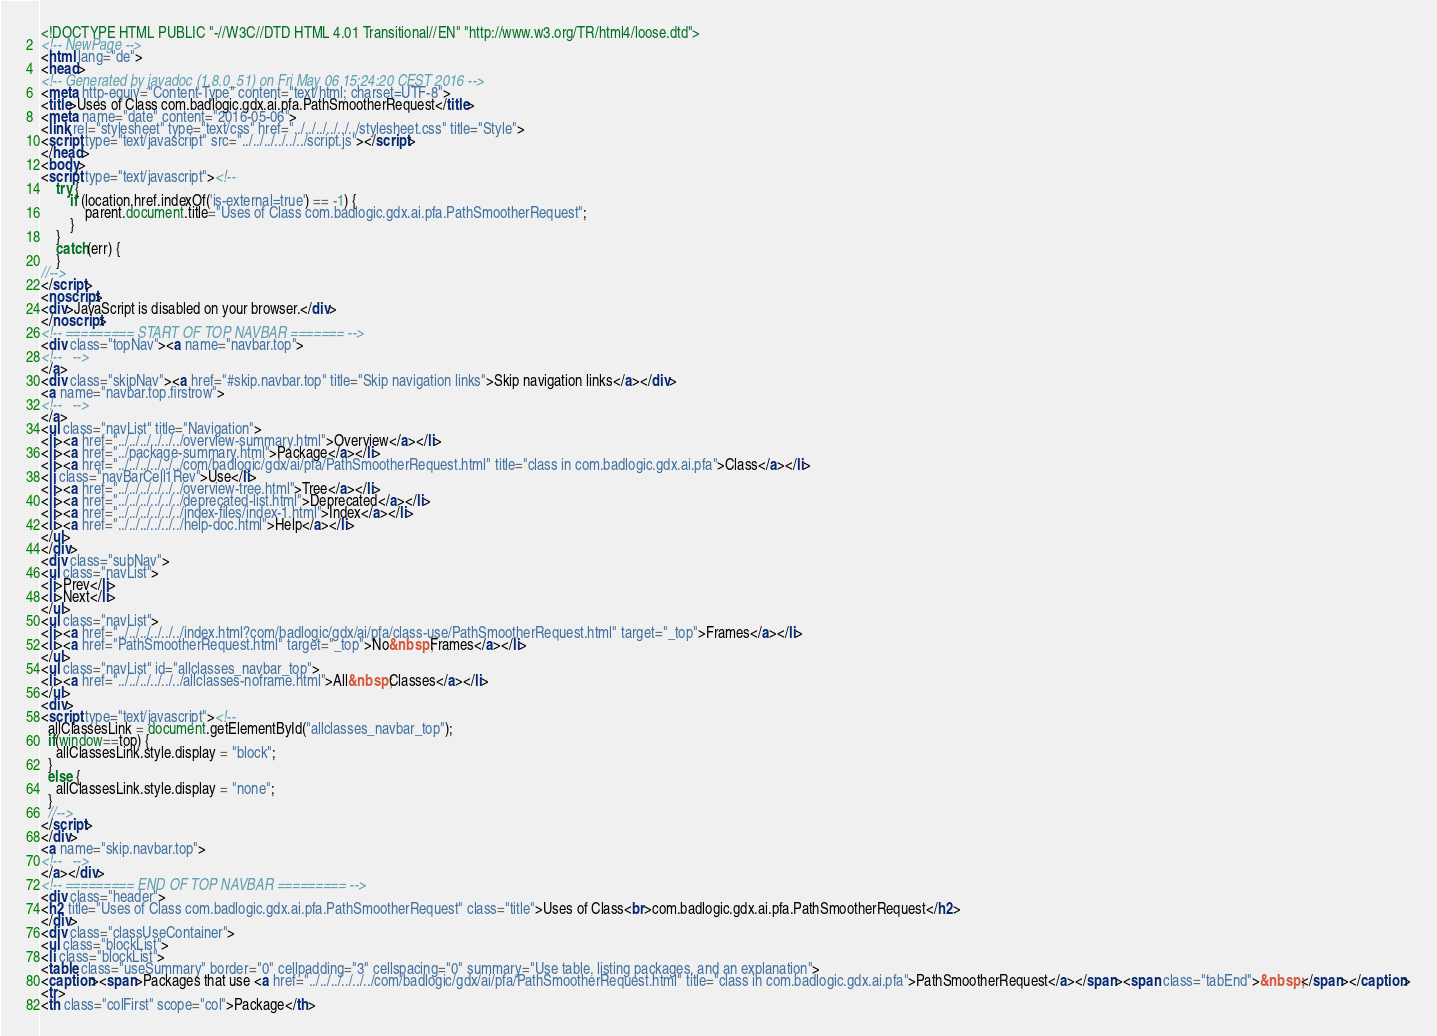<code> <loc_0><loc_0><loc_500><loc_500><_HTML_><!DOCTYPE HTML PUBLIC "-//W3C//DTD HTML 4.01 Transitional//EN" "http://www.w3.org/TR/html4/loose.dtd">
<!-- NewPage -->
<html lang="de">
<head>
<!-- Generated by javadoc (1.8.0_51) on Fri May 06 15:24:20 CEST 2016 -->
<meta http-equiv="Content-Type" content="text/html; charset=UTF-8">
<title>Uses of Class com.badlogic.gdx.ai.pfa.PathSmootherRequest</title>
<meta name="date" content="2016-05-06">
<link rel="stylesheet" type="text/css" href="../../../../../../stylesheet.css" title="Style">
<script type="text/javascript" src="../../../../../../script.js"></script>
</head>
<body>
<script type="text/javascript"><!--
    try {
        if (location.href.indexOf('is-external=true') == -1) {
            parent.document.title="Uses of Class com.badlogic.gdx.ai.pfa.PathSmootherRequest";
        }
    }
    catch(err) {
    }
//-->
</script>
<noscript>
<div>JavaScript is disabled on your browser.</div>
</noscript>
<!-- ========= START OF TOP NAVBAR ======= -->
<div class="topNav"><a name="navbar.top">
<!--   -->
</a>
<div class="skipNav"><a href="#skip.navbar.top" title="Skip navigation links">Skip navigation links</a></div>
<a name="navbar.top.firstrow">
<!--   -->
</a>
<ul class="navList" title="Navigation">
<li><a href="../../../../../../overview-summary.html">Overview</a></li>
<li><a href="../package-summary.html">Package</a></li>
<li><a href="../../../../../../com/badlogic/gdx/ai/pfa/PathSmootherRequest.html" title="class in com.badlogic.gdx.ai.pfa">Class</a></li>
<li class="navBarCell1Rev">Use</li>
<li><a href="../../../../../../overview-tree.html">Tree</a></li>
<li><a href="../../../../../../deprecated-list.html">Deprecated</a></li>
<li><a href="../../../../../../index-files/index-1.html">Index</a></li>
<li><a href="../../../../../../help-doc.html">Help</a></li>
</ul>
</div>
<div class="subNav">
<ul class="navList">
<li>Prev</li>
<li>Next</li>
</ul>
<ul class="navList">
<li><a href="../../../../../../index.html?com/badlogic/gdx/ai/pfa/class-use/PathSmootherRequest.html" target="_top">Frames</a></li>
<li><a href="PathSmootherRequest.html" target="_top">No&nbsp;Frames</a></li>
</ul>
<ul class="navList" id="allclasses_navbar_top">
<li><a href="../../../../../../allclasses-noframe.html">All&nbsp;Classes</a></li>
</ul>
<div>
<script type="text/javascript"><!--
  allClassesLink = document.getElementById("allclasses_navbar_top");
  if(window==top) {
    allClassesLink.style.display = "block";
  }
  else {
    allClassesLink.style.display = "none";
  }
  //-->
</script>
</div>
<a name="skip.navbar.top">
<!--   -->
</a></div>
<!-- ========= END OF TOP NAVBAR ========= -->
<div class="header">
<h2 title="Uses of Class com.badlogic.gdx.ai.pfa.PathSmootherRequest" class="title">Uses of Class<br>com.badlogic.gdx.ai.pfa.PathSmootherRequest</h2>
</div>
<div class="classUseContainer">
<ul class="blockList">
<li class="blockList">
<table class="useSummary" border="0" cellpadding="3" cellspacing="0" summary="Use table, listing packages, and an explanation">
<caption><span>Packages that use <a href="../../../../../../com/badlogic/gdx/ai/pfa/PathSmootherRequest.html" title="class in com.badlogic.gdx.ai.pfa">PathSmootherRequest</a></span><span class="tabEnd">&nbsp;</span></caption>
<tr>
<th class="colFirst" scope="col">Package</th></code> 